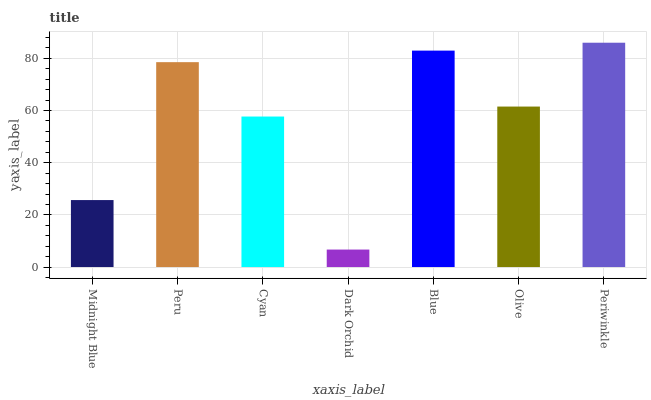Is Dark Orchid the minimum?
Answer yes or no. Yes. Is Periwinkle the maximum?
Answer yes or no. Yes. Is Peru the minimum?
Answer yes or no. No. Is Peru the maximum?
Answer yes or no. No. Is Peru greater than Midnight Blue?
Answer yes or no. Yes. Is Midnight Blue less than Peru?
Answer yes or no. Yes. Is Midnight Blue greater than Peru?
Answer yes or no. No. Is Peru less than Midnight Blue?
Answer yes or no. No. Is Olive the high median?
Answer yes or no. Yes. Is Olive the low median?
Answer yes or no. Yes. Is Dark Orchid the high median?
Answer yes or no. No. Is Periwinkle the low median?
Answer yes or no. No. 